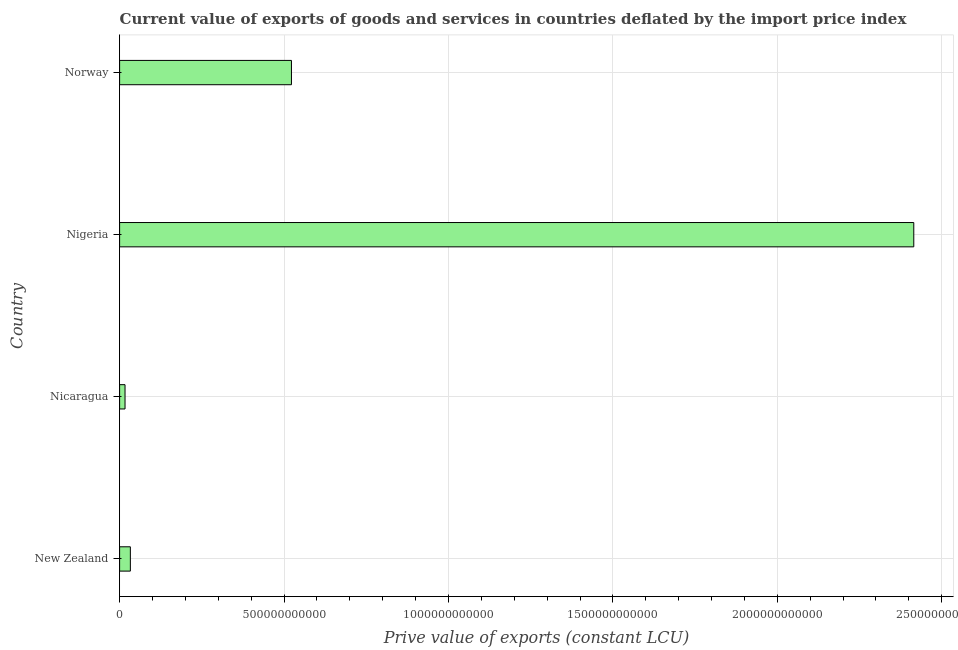Does the graph contain any zero values?
Offer a very short reply. No. What is the title of the graph?
Your answer should be very brief. Current value of exports of goods and services in countries deflated by the import price index. What is the label or title of the X-axis?
Ensure brevity in your answer.  Prive value of exports (constant LCU). What is the price value of exports in New Zealand?
Offer a very short reply. 3.27e+1. Across all countries, what is the maximum price value of exports?
Your response must be concise. 2.42e+12. Across all countries, what is the minimum price value of exports?
Provide a short and direct response. 1.65e+1. In which country was the price value of exports maximum?
Make the answer very short. Nigeria. In which country was the price value of exports minimum?
Ensure brevity in your answer.  Nicaragua. What is the sum of the price value of exports?
Ensure brevity in your answer.  2.99e+12. What is the difference between the price value of exports in New Zealand and Nicaragua?
Provide a succinct answer. 1.62e+1. What is the average price value of exports per country?
Provide a short and direct response. 7.47e+11. What is the median price value of exports?
Your answer should be compact. 2.78e+11. In how many countries, is the price value of exports greater than 900000000000 LCU?
Your answer should be compact. 1. What is the ratio of the price value of exports in Nicaragua to that in Nigeria?
Give a very brief answer. 0.01. What is the difference between the highest and the second highest price value of exports?
Your answer should be compact. 1.89e+12. Is the sum of the price value of exports in Nicaragua and Norway greater than the maximum price value of exports across all countries?
Provide a short and direct response. No. What is the difference between the highest and the lowest price value of exports?
Provide a succinct answer. 2.40e+12. In how many countries, is the price value of exports greater than the average price value of exports taken over all countries?
Make the answer very short. 1. How many bars are there?
Keep it short and to the point. 4. Are all the bars in the graph horizontal?
Your response must be concise. Yes. What is the difference between two consecutive major ticks on the X-axis?
Provide a short and direct response. 5.00e+11. What is the Prive value of exports (constant LCU) of New Zealand?
Offer a very short reply. 3.27e+1. What is the Prive value of exports (constant LCU) in Nicaragua?
Keep it short and to the point. 1.65e+1. What is the Prive value of exports (constant LCU) of Nigeria?
Make the answer very short. 2.42e+12. What is the Prive value of exports (constant LCU) of Norway?
Provide a succinct answer. 5.23e+11. What is the difference between the Prive value of exports (constant LCU) in New Zealand and Nicaragua?
Give a very brief answer. 1.62e+1. What is the difference between the Prive value of exports (constant LCU) in New Zealand and Nigeria?
Offer a very short reply. -2.38e+12. What is the difference between the Prive value of exports (constant LCU) in New Zealand and Norway?
Your answer should be very brief. -4.90e+11. What is the difference between the Prive value of exports (constant LCU) in Nicaragua and Nigeria?
Keep it short and to the point. -2.40e+12. What is the difference between the Prive value of exports (constant LCU) in Nicaragua and Norway?
Give a very brief answer. -5.06e+11. What is the difference between the Prive value of exports (constant LCU) in Nigeria and Norway?
Ensure brevity in your answer.  1.89e+12. What is the ratio of the Prive value of exports (constant LCU) in New Zealand to that in Nicaragua?
Your answer should be compact. 1.98. What is the ratio of the Prive value of exports (constant LCU) in New Zealand to that in Nigeria?
Your response must be concise. 0.01. What is the ratio of the Prive value of exports (constant LCU) in New Zealand to that in Norway?
Your answer should be very brief. 0.06. What is the ratio of the Prive value of exports (constant LCU) in Nicaragua to that in Nigeria?
Your answer should be compact. 0.01. What is the ratio of the Prive value of exports (constant LCU) in Nicaragua to that in Norway?
Provide a short and direct response. 0.03. What is the ratio of the Prive value of exports (constant LCU) in Nigeria to that in Norway?
Offer a terse response. 4.62. 